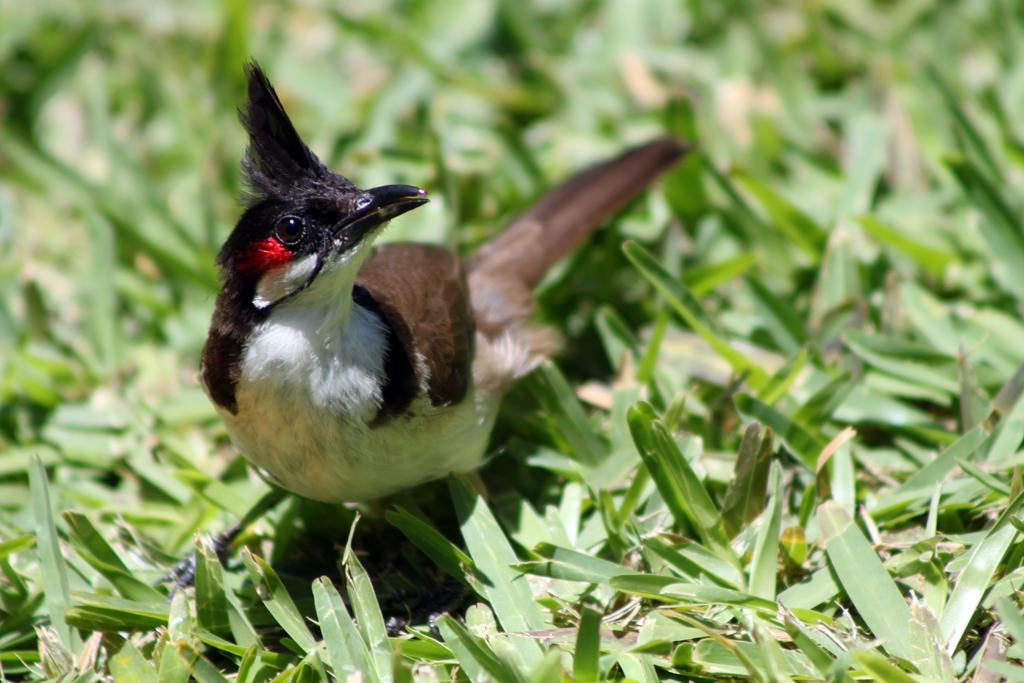What type of animal can be seen in the image? There is a bird in the image. Where is the bird located? The bird is on the surface of the grass. What type of wool is the bird using to sing a dinner song in the image? There is no wool, song, or dinner depicted in the image; it only features a bird on the grass. 